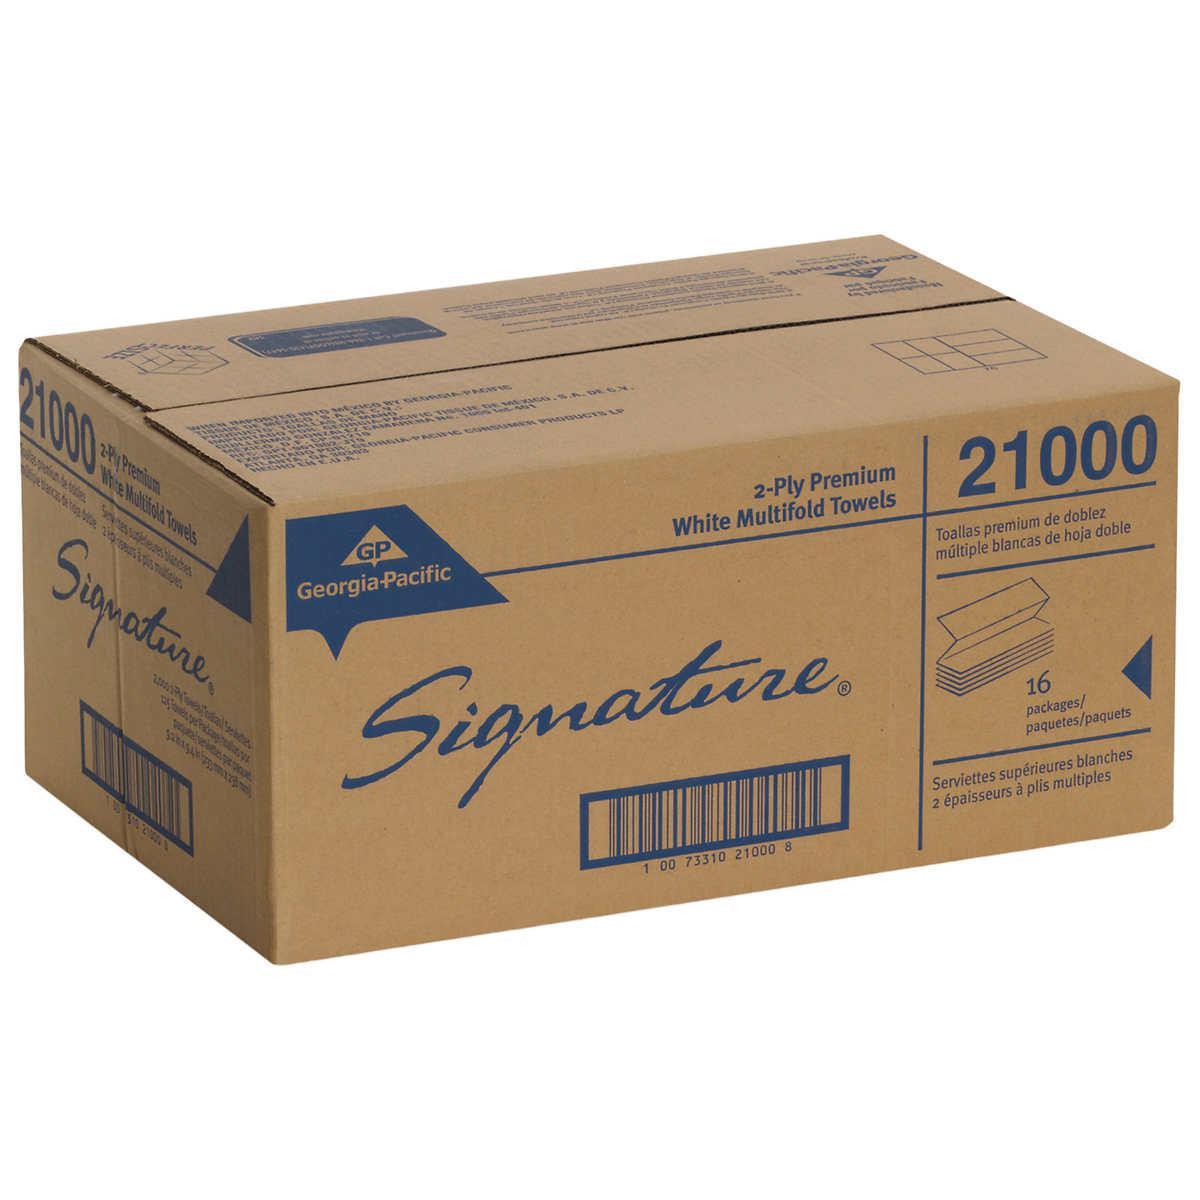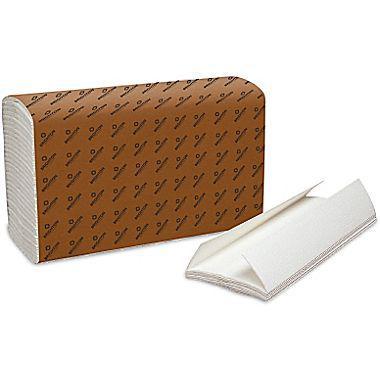The first image is the image on the left, the second image is the image on the right. Given the left and right images, does the statement "No paper rolls are shown, but a stack of folded towels in a brown wrapper and a cardboard box are shown." hold true? Answer yes or no. Yes. The first image is the image on the left, the second image is the image on the right. Examine the images to the left and right. Is the description "At least one of the paper products is available by the roll." accurate? Answer yes or no. No. 